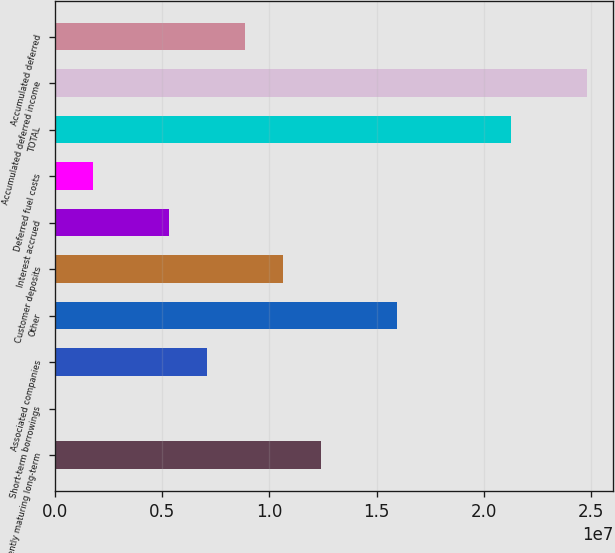<chart> <loc_0><loc_0><loc_500><loc_500><bar_chart><fcel>Currently maturing long-term<fcel>Short-term borrowings<fcel>Associated companies<fcel>Other<fcel>Customer deposits<fcel>Interest accrued<fcel>Deferred fuel costs<fcel>TOTAL<fcel>Accumulated deferred income<fcel>Accumulated deferred<nl><fcel>1.2392e+07<fcel>3794<fcel>7.08278e+06<fcel>1.59315e+07<fcel>1.06223e+07<fcel>5.31304e+06<fcel>1.77354e+06<fcel>2.12408e+07<fcel>2.47803e+07<fcel>8.85253e+06<nl></chart> 